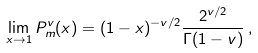<formula> <loc_0><loc_0><loc_500><loc_500>\lim _ { x \rightarrow 1 } P ^ { v } _ { m } ( x ) = ( 1 - x ) ^ { - v / 2 } \frac { 2 ^ { v / 2 } } { \Gamma ( 1 - v ) } \, ,</formula> 